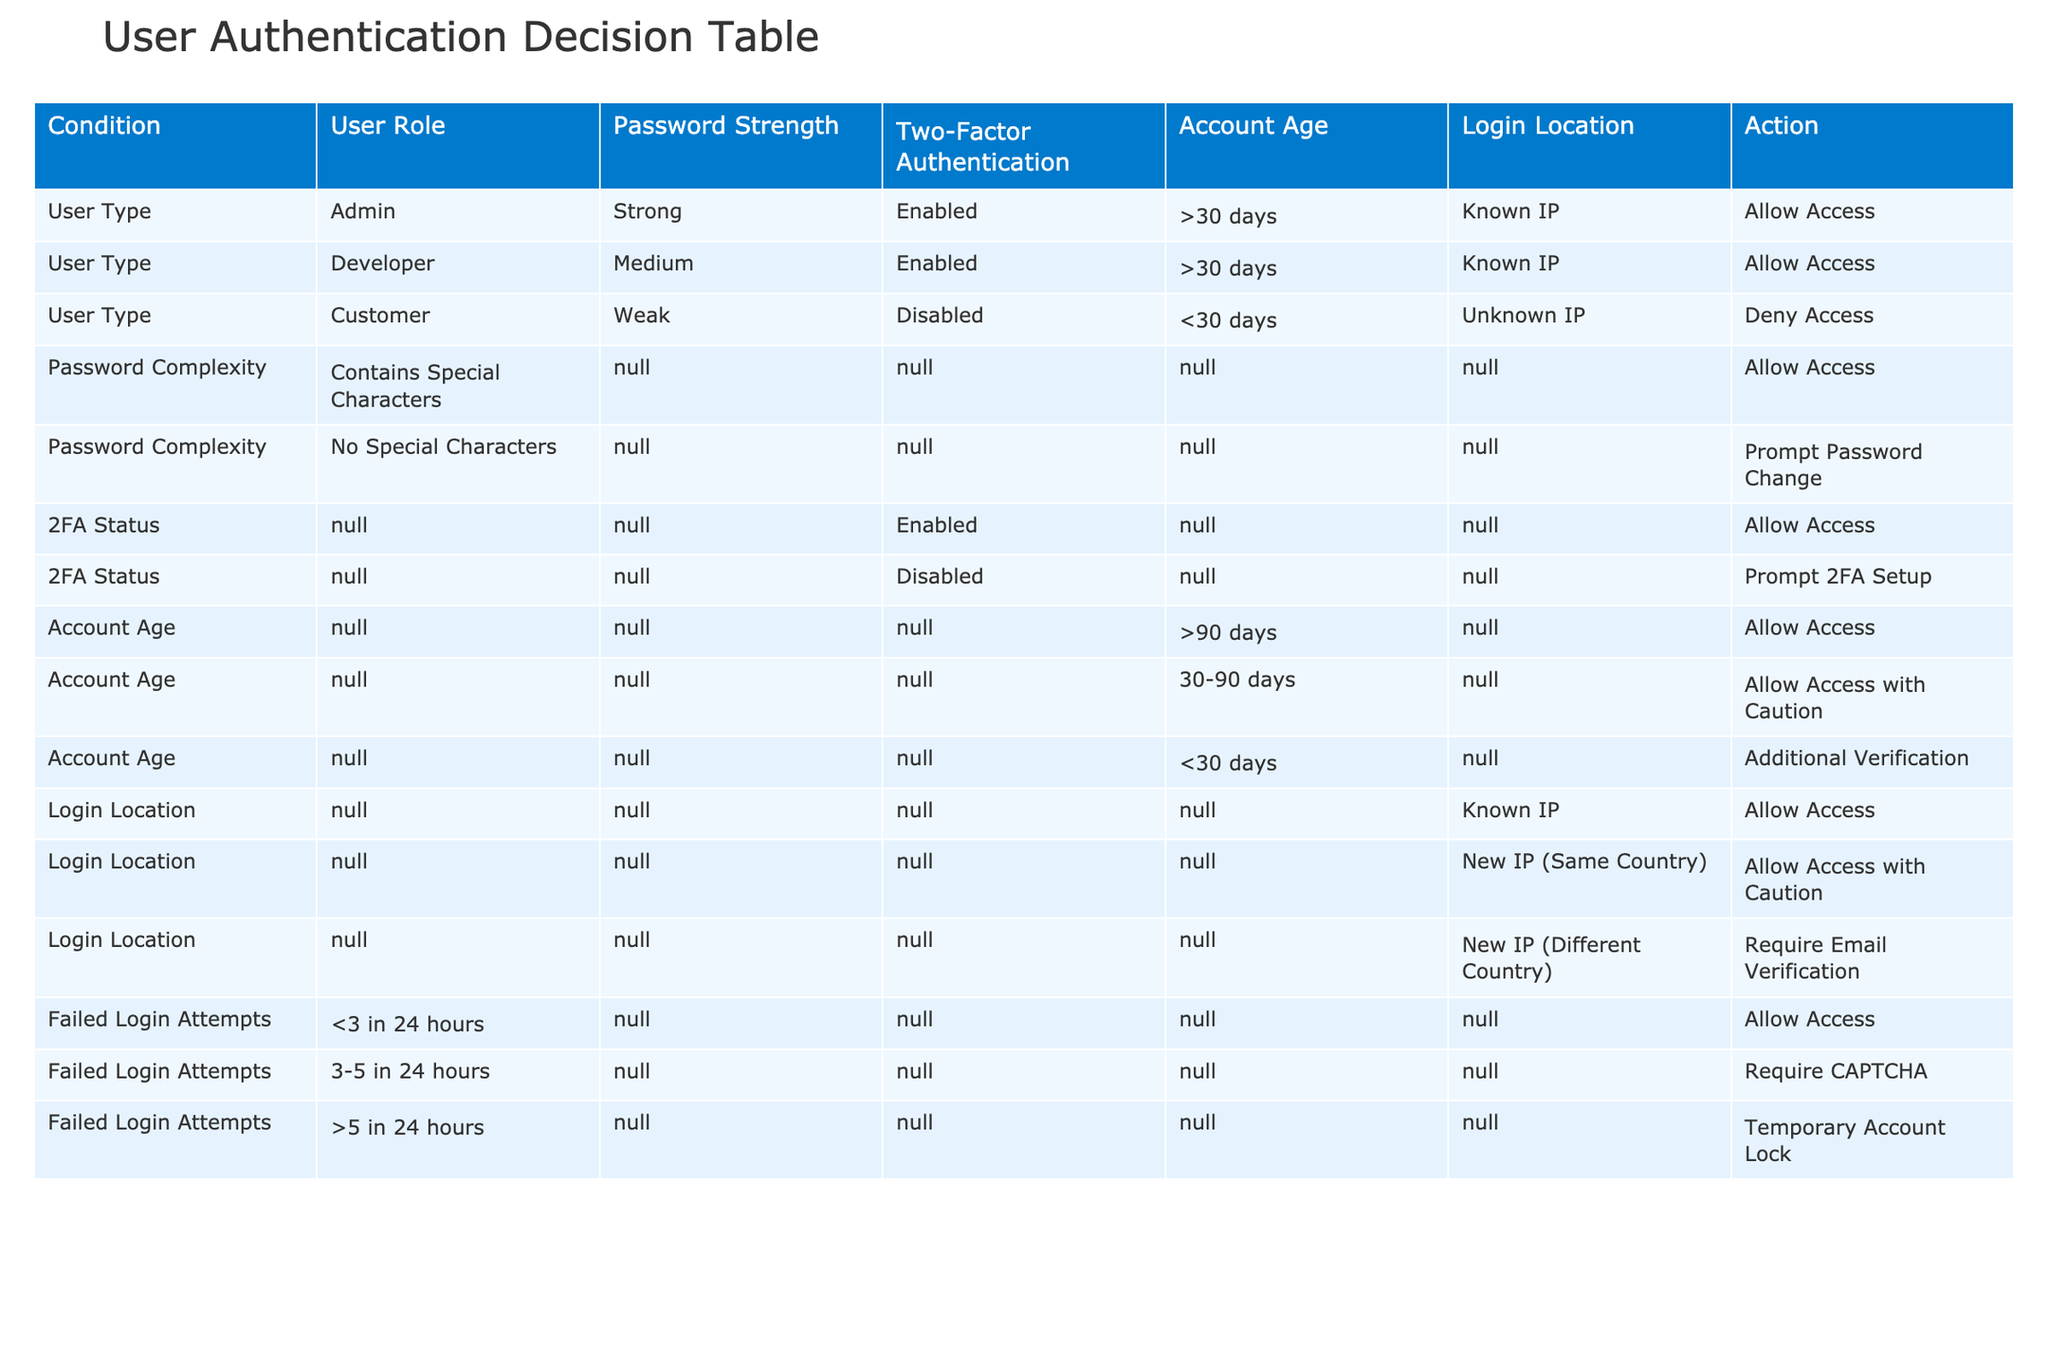What action is taken for an Admin with a strong password, 30 days old account, and located in a known IP? The table states that for an Admin role with a strong password, having the account age greater than 30 days, and logging in from a known IP, the action is to allow access.
Answer: Allow Access What happens if a customer tries to log in with a weak password from an unknown IP? According to the table, a customer with a weak password who attempts to log in from an unknown IP will be denied access.
Answer: Deny Access Is two-factor authentication enabled for all user types in the system? The table shows that two-factor authentication is only enabled for some user types and specific conditions, hence it is not universally enabled for all user types.
Answer: No What is the required action if there are more than five failed login attempts in 24 hours? The decision table indicates that if there are more than five failed login attempts in 24 hours, the action is to temporarily lock the account.
Answer: Temporary Account Lock For a developer with a medium password and a new IP in a different country, what is the action taken? According to the table, a developer with a medium password logging in from a new IP from a different country would require email verification, as both conditions pertain to the action needed.
Answer: Require Email Verification What percentage of users with strong passwords are allowed access based on the table's conditions? The table shows just one specific case for strong passwords (Admin); since there are no other cases with strong passwords that deny access, the percentage therefore remains at 100% allowed access.
Answer: 100% If a customer has logged in with a weak password from a known IP and it is over 90 days old, what action will be taken? In the table, a weak password does not permit access for customers, regardless of account age or IP status; hence they will be denied access.
Answer: Deny Access How would the action differ between a developer and a customer attempting to log in with a medium strength password from a known IP? The table states that both will be allowed access if the password strength is medium, but for a customer, a weak password from an unknown IP will prompt a denial, whereas the developer's login is permitted.
Answer: Allow Access for Developer, Deny Access for Customer What verification is necessary for a user with an account less than 30 days old trying to log in from a new IP in the same country? The table indicates that for accounts under 30 days, the system requires additional verification regardless of the IP; hence the user must go through an extra verification process to gain access.
Answer: Additional Verification 